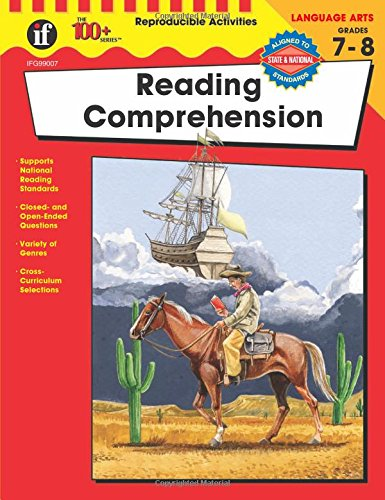Is this book related to Cookbooks, Food & Wine? No, this book is unrelated to cookbooks, food, or wine. It is solely focused on academic enhancement in reading comprehension for middle school students. 